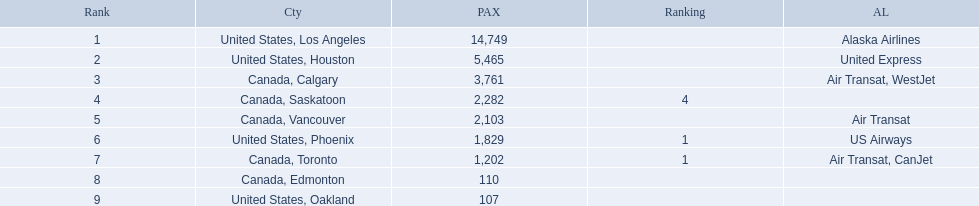Which cities had less than 2,000 passengers? United States, Phoenix, Canada, Toronto, Canada, Edmonton, United States, Oakland. Of these cities, which had fewer than 1,000 passengers? Canada, Edmonton, United States, Oakland. Of the cities in the previous answer, which one had only 107 passengers? United States, Oakland. 